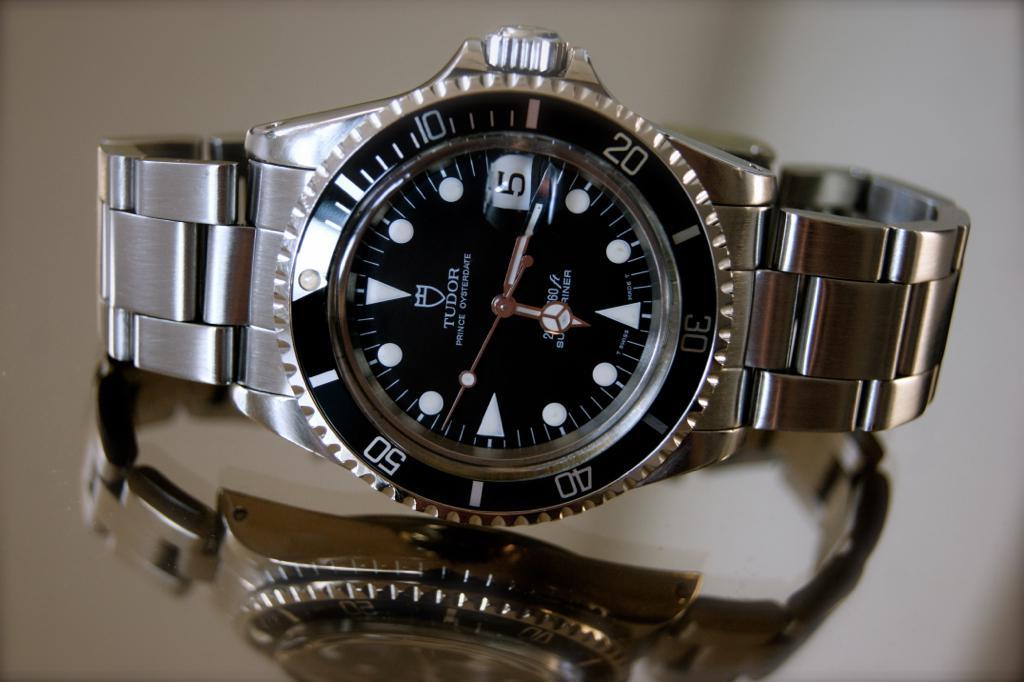What brand is this watch?
Ensure brevity in your answer.  Tudor. What time is shown on the watch?
Keep it short and to the point. 6:17. 